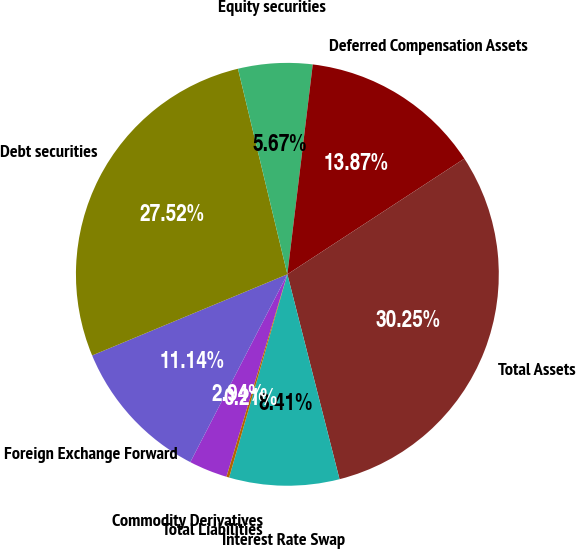<chart> <loc_0><loc_0><loc_500><loc_500><pie_chart><fcel>Commodity Derivatives<fcel>Foreign Exchange Forward<fcel>Debt securities<fcel>Equity securities<fcel>Deferred Compensation Assets<fcel>Total Assets<fcel>Interest Rate Swap<fcel>Total Liabilities<nl><fcel>2.94%<fcel>11.14%<fcel>27.52%<fcel>5.67%<fcel>13.87%<fcel>30.25%<fcel>8.41%<fcel>0.21%<nl></chart> 